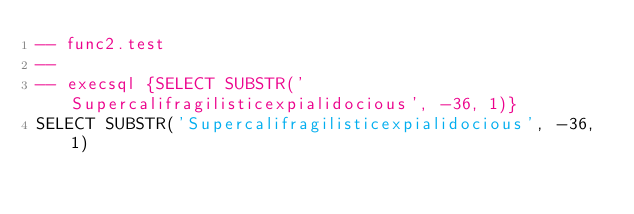Convert code to text. <code><loc_0><loc_0><loc_500><loc_500><_SQL_>-- func2.test
-- 
-- execsql {SELECT SUBSTR('Supercalifragilisticexpialidocious', -36, 1)}
SELECT SUBSTR('Supercalifragilisticexpialidocious', -36, 1)</code> 